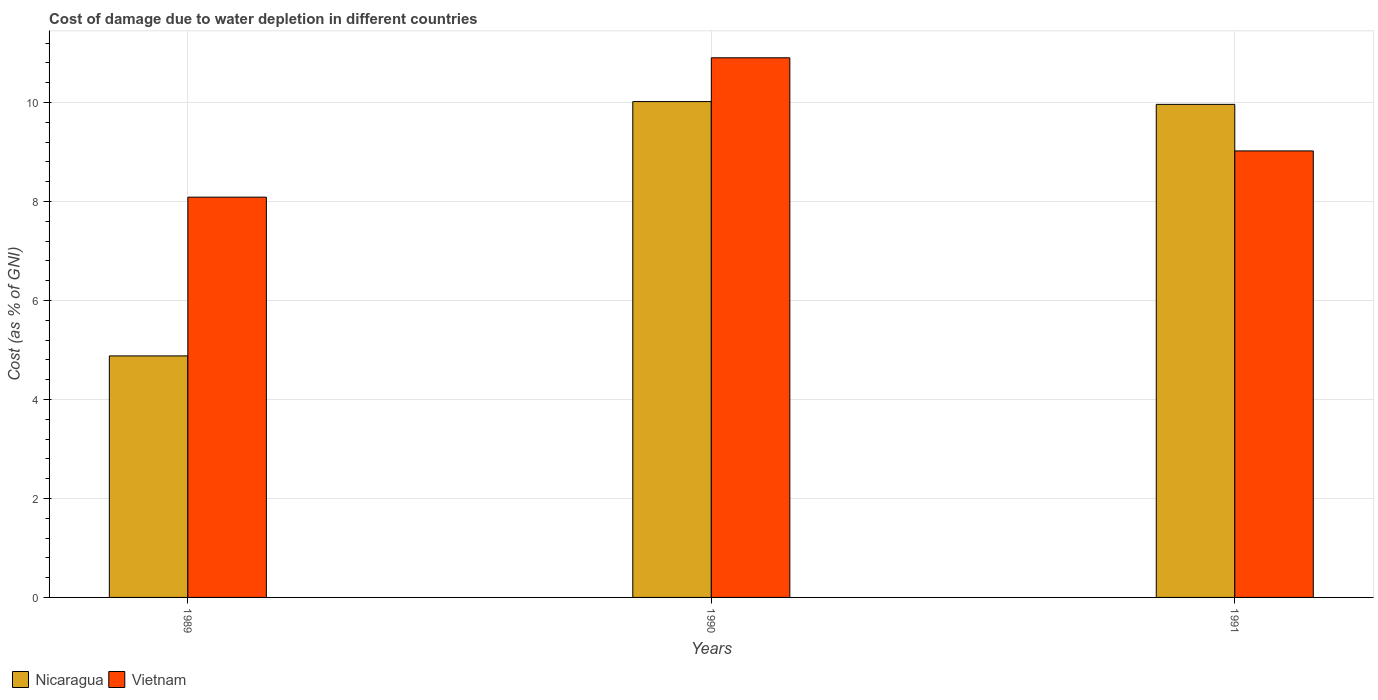Are the number of bars on each tick of the X-axis equal?
Keep it short and to the point. Yes. How many bars are there on the 1st tick from the left?
Ensure brevity in your answer.  2. How many bars are there on the 2nd tick from the right?
Offer a terse response. 2. What is the label of the 3rd group of bars from the left?
Provide a short and direct response. 1991. In how many cases, is the number of bars for a given year not equal to the number of legend labels?
Your answer should be very brief. 0. What is the cost of damage caused due to water depletion in Nicaragua in 1990?
Give a very brief answer. 10.02. Across all years, what is the maximum cost of damage caused due to water depletion in Vietnam?
Provide a succinct answer. 10.9. Across all years, what is the minimum cost of damage caused due to water depletion in Vietnam?
Your response must be concise. 8.09. In which year was the cost of damage caused due to water depletion in Nicaragua minimum?
Provide a succinct answer. 1989. What is the total cost of damage caused due to water depletion in Nicaragua in the graph?
Provide a short and direct response. 24.86. What is the difference between the cost of damage caused due to water depletion in Nicaragua in 1989 and that in 1990?
Offer a terse response. -5.14. What is the difference between the cost of damage caused due to water depletion in Nicaragua in 1991 and the cost of damage caused due to water depletion in Vietnam in 1990?
Offer a terse response. -0.94. What is the average cost of damage caused due to water depletion in Vietnam per year?
Ensure brevity in your answer.  9.34. In the year 1989, what is the difference between the cost of damage caused due to water depletion in Nicaragua and cost of damage caused due to water depletion in Vietnam?
Provide a succinct answer. -3.21. In how many years, is the cost of damage caused due to water depletion in Vietnam greater than 2.8 %?
Offer a terse response. 3. What is the ratio of the cost of damage caused due to water depletion in Vietnam in 1990 to that in 1991?
Offer a very short reply. 1.21. Is the cost of damage caused due to water depletion in Nicaragua in 1990 less than that in 1991?
Ensure brevity in your answer.  No. Is the difference between the cost of damage caused due to water depletion in Nicaragua in 1989 and 1991 greater than the difference between the cost of damage caused due to water depletion in Vietnam in 1989 and 1991?
Provide a short and direct response. No. What is the difference between the highest and the second highest cost of damage caused due to water depletion in Nicaragua?
Ensure brevity in your answer.  0.06. What is the difference between the highest and the lowest cost of damage caused due to water depletion in Nicaragua?
Provide a succinct answer. 5.14. In how many years, is the cost of damage caused due to water depletion in Vietnam greater than the average cost of damage caused due to water depletion in Vietnam taken over all years?
Your response must be concise. 1. What does the 1st bar from the left in 1990 represents?
Your response must be concise. Nicaragua. What does the 1st bar from the right in 1990 represents?
Provide a succinct answer. Vietnam. How many years are there in the graph?
Your response must be concise. 3. What is the difference between two consecutive major ticks on the Y-axis?
Your response must be concise. 2. Does the graph contain any zero values?
Keep it short and to the point. No. Where does the legend appear in the graph?
Make the answer very short. Bottom left. How are the legend labels stacked?
Ensure brevity in your answer.  Horizontal. What is the title of the graph?
Your answer should be compact. Cost of damage due to water depletion in different countries. What is the label or title of the Y-axis?
Offer a very short reply. Cost (as % of GNI). What is the Cost (as % of GNI) in Nicaragua in 1989?
Your answer should be very brief. 4.88. What is the Cost (as % of GNI) in Vietnam in 1989?
Your answer should be very brief. 8.09. What is the Cost (as % of GNI) in Nicaragua in 1990?
Your answer should be very brief. 10.02. What is the Cost (as % of GNI) in Vietnam in 1990?
Your answer should be compact. 10.9. What is the Cost (as % of GNI) in Nicaragua in 1991?
Provide a short and direct response. 9.96. What is the Cost (as % of GNI) of Vietnam in 1991?
Ensure brevity in your answer.  9.02. Across all years, what is the maximum Cost (as % of GNI) in Nicaragua?
Ensure brevity in your answer.  10.02. Across all years, what is the maximum Cost (as % of GNI) in Vietnam?
Give a very brief answer. 10.9. Across all years, what is the minimum Cost (as % of GNI) of Nicaragua?
Keep it short and to the point. 4.88. Across all years, what is the minimum Cost (as % of GNI) of Vietnam?
Give a very brief answer. 8.09. What is the total Cost (as % of GNI) in Nicaragua in the graph?
Your answer should be very brief. 24.86. What is the total Cost (as % of GNI) of Vietnam in the graph?
Your answer should be very brief. 28.02. What is the difference between the Cost (as % of GNI) of Nicaragua in 1989 and that in 1990?
Offer a very short reply. -5.14. What is the difference between the Cost (as % of GNI) in Vietnam in 1989 and that in 1990?
Ensure brevity in your answer.  -2.82. What is the difference between the Cost (as % of GNI) in Nicaragua in 1989 and that in 1991?
Give a very brief answer. -5.08. What is the difference between the Cost (as % of GNI) of Vietnam in 1989 and that in 1991?
Give a very brief answer. -0.93. What is the difference between the Cost (as % of GNI) in Nicaragua in 1990 and that in 1991?
Make the answer very short. 0.06. What is the difference between the Cost (as % of GNI) in Vietnam in 1990 and that in 1991?
Provide a succinct answer. 1.88. What is the difference between the Cost (as % of GNI) in Nicaragua in 1989 and the Cost (as % of GNI) in Vietnam in 1990?
Your answer should be very brief. -6.02. What is the difference between the Cost (as % of GNI) of Nicaragua in 1989 and the Cost (as % of GNI) of Vietnam in 1991?
Provide a succinct answer. -4.14. What is the difference between the Cost (as % of GNI) in Nicaragua in 1990 and the Cost (as % of GNI) in Vietnam in 1991?
Your answer should be compact. 1. What is the average Cost (as % of GNI) of Nicaragua per year?
Ensure brevity in your answer.  8.29. What is the average Cost (as % of GNI) in Vietnam per year?
Your response must be concise. 9.34. In the year 1989, what is the difference between the Cost (as % of GNI) of Nicaragua and Cost (as % of GNI) of Vietnam?
Your answer should be very brief. -3.21. In the year 1990, what is the difference between the Cost (as % of GNI) in Nicaragua and Cost (as % of GNI) in Vietnam?
Your answer should be very brief. -0.88. In the year 1991, what is the difference between the Cost (as % of GNI) of Nicaragua and Cost (as % of GNI) of Vietnam?
Provide a short and direct response. 0.94. What is the ratio of the Cost (as % of GNI) in Nicaragua in 1989 to that in 1990?
Offer a terse response. 0.49. What is the ratio of the Cost (as % of GNI) of Vietnam in 1989 to that in 1990?
Give a very brief answer. 0.74. What is the ratio of the Cost (as % of GNI) of Nicaragua in 1989 to that in 1991?
Give a very brief answer. 0.49. What is the ratio of the Cost (as % of GNI) in Vietnam in 1989 to that in 1991?
Offer a terse response. 0.9. What is the ratio of the Cost (as % of GNI) of Vietnam in 1990 to that in 1991?
Make the answer very short. 1.21. What is the difference between the highest and the second highest Cost (as % of GNI) of Nicaragua?
Offer a terse response. 0.06. What is the difference between the highest and the second highest Cost (as % of GNI) of Vietnam?
Your answer should be very brief. 1.88. What is the difference between the highest and the lowest Cost (as % of GNI) in Nicaragua?
Your answer should be compact. 5.14. What is the difference between the highest and the lowest Cost (as % of GNI) in Vietnam?
Give a very brief answer. 2.82. 